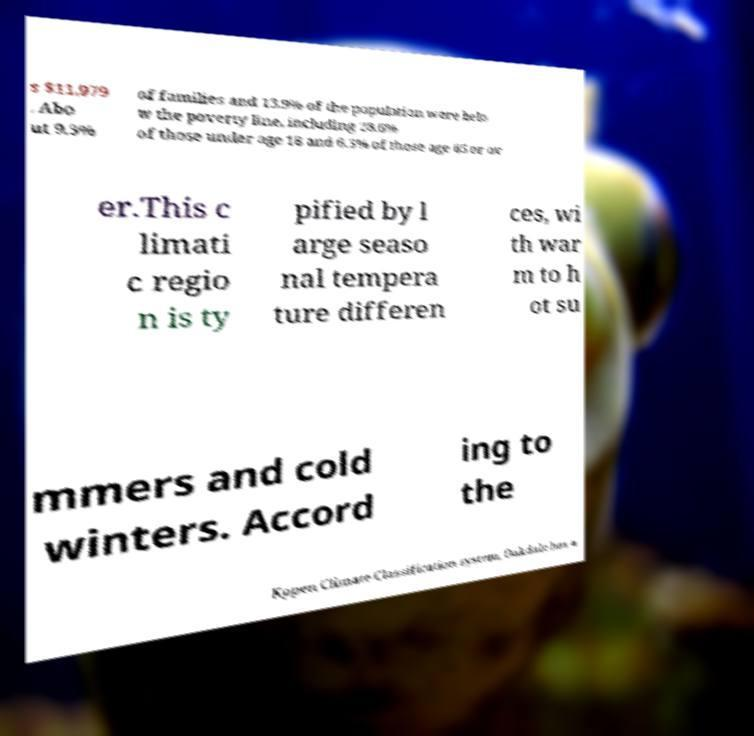Can you read and provide the text displayed in the image?This photo seems to have some interesting text. Can you extract and type it out for me? s $11,979 . Abo ut 9.3% of families and 13.9% of the population were belo w the poverty line, including 28.6% of those under age 18 and 6.3% of those age 65 or ov er.This c limati c regio n is ty pified by l arge seaso nal tempera ture differen ces, wi th war m to h ot su mmers and cold winters. Accord ing to the Kppen Climate Classification system, Oakdale has a 